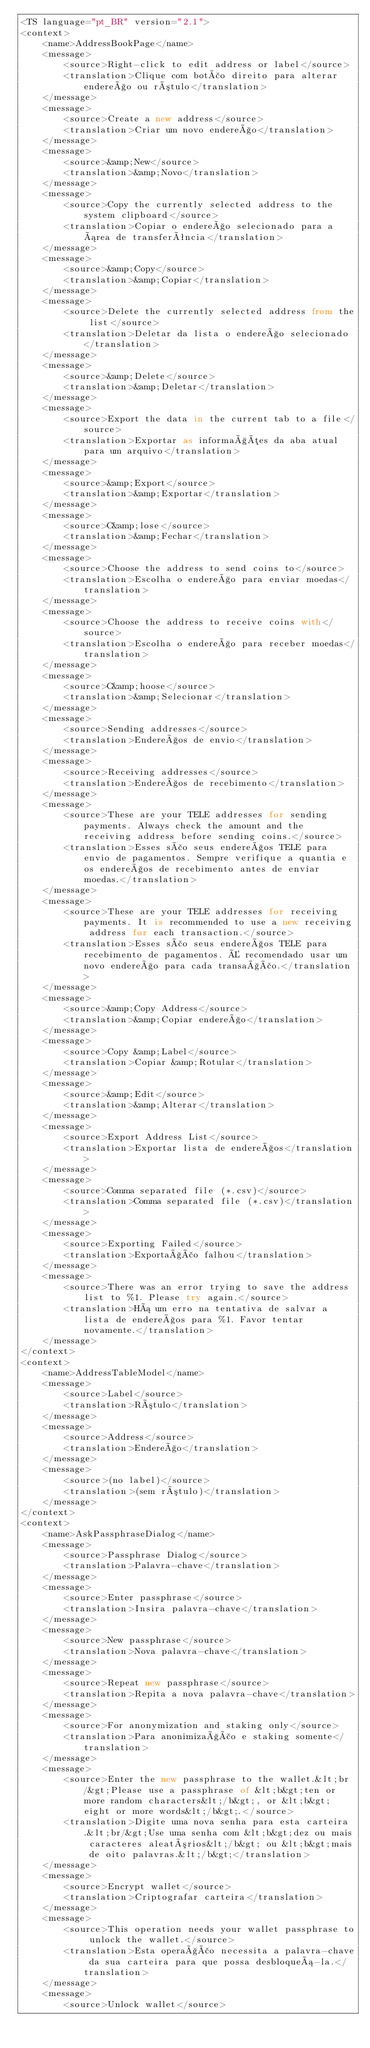Convert code to text. <code><loc_0><loc_0><loc_500><loc_500><_TypeScript_><TS language="pt_BR" version="2.1">
<context>
    <name>AddressBookPage</name>
    <message>
        <source>Right-click to edit address or label</source>
        <translation>Clique com botão direito para alterar endereço ou rótulo</translation>
    </message>
    <message>
        <source>Create a new address</source>
        <translation>Criar um novo endereço</translation>
    </message>
    <message>
        <source>&amp;New</source>
        <translation>&amp;Novo</translation>
    </message>
    <message>
        <source>Copy the currently selected address to the system clipboard</source>
        <translation>Copiar o endereço selecionado para a área de transferência</translation>
    </message>
    <message>
        <source>&amp;Copy</source>
        <translation>&amp;Copiar</translation>
    </message>
    <message>
        <source>Delete the currently selected address from the list</source>
        <translation>Deletar da lista o endereço selecionado </translation>
    </message>
    <message>
        <source>&amp;Delete</source>
        <translation>&amp;Deletar</translation>
    </message>
    <message>
        <source>Export the data in the current tab to a file</source>
        <translation>Exportar as informações da aba atual para um arquivo</translation>
    </message>
    <message>
        <source>&amp;Export</source>
        <translation>&amp;Exportar</translation>
    </message>
    <message>
        <source>C&amp;lose</source>
        <translation>&amp;Fechar</translation>
    </message>
    <message>
        <source>Choose the address to send coins to</source>
        <translation>Escolha o endereço para enviar moedas</translation>
    </message>
    <message>
        <source>Choose the address to receive coins with</source>
        <translation>Escolha o endereço para receber moedas</translation>
    </message>
    <message>
        <source>C&amp;hoose</source>
        <translation>&amp;Selecionar</translation>
    </message>
    <message>
        <source>Sending addresses</source>
        <translation>Endereços de envio</translation>
    </message>
    <message>
        <source>Receiving addresses</source>
        <translation>Endereços de recebimento</translation>
    </message>
    <message>
        <source>These are your TELE addresses for sending payments. Always check the amount and the receiving address before sending coins.</source>
        <translation>Esses são seus endereços TELE para envio de pagamentos. Sempre verifique a quantia e os endereços de recebimento antes de enviar moedas.</translation>
    </message>
    <message>
        <source>These are your TELE addresses for receiving payments. It is recommended to use a new receiving address for each transaction.</source>
        <translation>Esses são seus endereços TELE para recebimento de pagamentos. É recomendado usar um novo endereço para cada transação.</translation>
    </message>
    <message>
        <source>&amp;Copy Address</source>
        <translation>&amp;Copiar endereço</translation>
    </message>
    <message>
        <source>Copy &amp;Label</source>
        <translation>Copiar &amp;Rotular</translation>
    </message>
    <message>
        <source>&amp;Edit</source>
        <translation>&amp;Alterar</translation>
    </message>
    <message>
        <source>Export Address List</source>
        <translation>Exportar lista de endereços</translation>
    </message>
    <message>
        <source>Comma separated file (*.csv)</source>
        <translation>Comma separated file (*.csv)</translation>
    </message>
    <message>
        <source>Exporting Failed</source>
        <translation>Exportação falhou</translation>
    </message>
    <message>
        <source>There was an error trying to save the address list to %1. Please try again.</source>
        <translation>Há um erro na tentativa de salvar a lista de endereços para %1. Favor tentar novamente.</translation>
    </message>
</context>
<context>
    <name>AddressTableModel</name>
    <message>
        <source>Label</source>
        <translation>Rótulo</translation>
    </message>
    <message>
        <source>Address</source>
        <translation>Endereço</translation>
    </message>
    <message>
        <source>(no label)</source>
        <translation>(sem rótulo)</translation>
    </message>
</context>
<context>
    <name>AskPassphraseDialog</name>
    <message>
        <source>Passphrase Dialog</source>
        <translation>Palavra-chave</translation>
    </message>
    <message>
        <source>Enter passphrase</source>
        <translation>Insira palavra-chave</translation>
    </message>
    <message>
        <source>New passphrase</source>
        <translation>Nova palavra-chave</translation>
    </message>
    <message>
        <source>Repeat new passphrase</source>
        <translation>Repita a nova palavra-chave</translation>
    </message>
    <message>
        <source>For anonymization and staking only</source>
        <translation>Para anonimização e staking somente</translation>
    </message>
    <message>
        <source>Enter the new passphrase to the wallet.&lt;br/&gt;Please use a passphrase of &lt;b&gt;ten or more random characters&lt;/b&gt;, or &lt;b&gt;eight or more words&lt;/b&gt;.</source>
        <translation>Digite uma nova senha para esta carteira.&lt;br/&gt;Use uma senha com &lt;b&gt;dez ou mais caracteres aleatórios&lt;/b&gt; ou &lt;b&gt;mais de oito palavras.&lt;/b&gt;</translation>
    </message>
    <message>
        <source>Encrypt wallet</source>
        <translation>Criptografar carteira</translation>
    </message>
    <message>
        <source>This operation needs your wallet passphrase to unlock the wallet.</source>
        <translation>Esta operação necessita a palavra-chave da sua carteira para que possa desbloqueá-la.</translation>
    </message>
    <message>
        <source>Unlock wallet</source></code> 